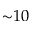Convert formula to latex. <formula><loc_0><loc_0><loc_500><loc_500>{ \sim } 1 0</formula> 